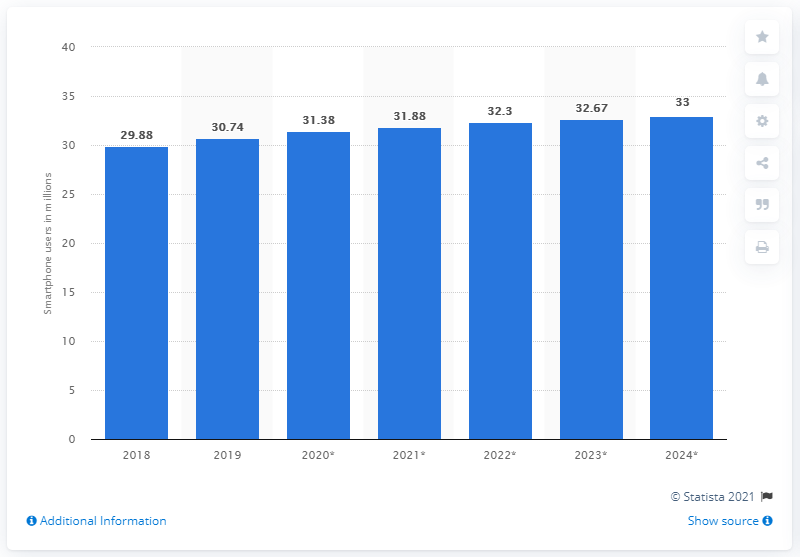Mention a couple of crucial points in this snapshot. According to estimates, there will be approximately 31.38 million smartphone users in Canada in 2020. 